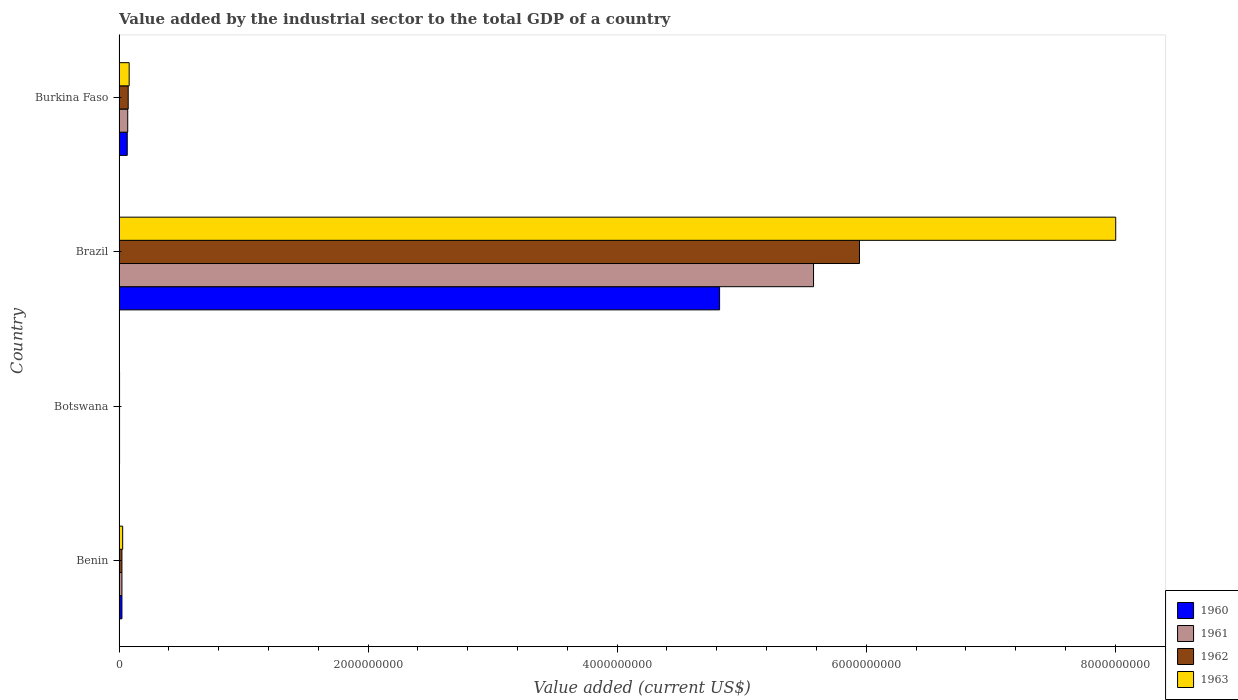How many different coloured bars are there?
Ensure brevity in your answer.  4. How many groups of bars are there?
Your answer should be very brief. 4. Are the number of bars on each tick of the Y-axis equal?
Offer a terse response. Yes. What is the label of the 4th group of bars from the top?
Your answer should be very brief. Benin. What is the value added by the industrial sector to the total GDP in 1962 in Brazil?
Ensure brevity in your answer.  5.95e+09. Across all countries, what is the maximum value added by the industrial sector to the total GDP in 1960?
Offer a terse response. 4.82e+09. Across all countries, what is the minimum value added by the industrial sector to the total GDP in 1961?
Provide a short and direct response. 4.05e+06. In which country was the value added by the industrial sector to the total GDP in 1963 minimum?
Ensure brevity in your answer.  Botswana. What is the total value added by the industrial sector to the total GDP in 1963 in the graph?
Your answer should be compact. 8.12e+09. What is the difference between the value added by the industrial sector to the total GDP in 1963 in Benin and that in Brazil?
Keep it short and to the point. -7.97e+09. What is the difference between the value added by the industrial sector to the total GDP in 1963 in Brazil and the value added by the industrial sector to the total GDP in 1962 in Burkina Faso?
Your answer should be very brief. 7.93e+09. What is the average value added by the industrial sector to the total GDP in 1960 per country?
Offer a very short reply. 1.23e+09. What is the difference between the value added by the industrial sector to the total GDP in 1963 and value added by the industrial sector to the total GDP in 1962 in Burkina Faso?
Your answer should be very brief. 7.75e+06. What is the ratio of the value added by the industrial sector to the total GDP in 1960 in Brazil to that in Burkina Faso?
Offer a terse response. 73.29. Is the value added by the industrial sector to the total GDP in 1961 in Brazil less than that in Burkina Faso?
Keep it short and to the point. No. Is the difference between the value added by the industrial sector to the total GDP in 1963 in Benin and Burkina Faso greater than the difference between the value added by the industrial sector to the total GDP in 1962 in Benin and Burkina Faso?
Keep it short and to the point. No. What is the difference between the highest and the second highest value added by the industrial sector to the total GDP in 1963?
Provide a short and direct response. 7.92e+09. What is the difference between the highest and the lowest value added by the industrial sector to the total GDP in 1963?
Offer a very short reply. 8.00e+09. In how many countries, is the value added by the industrial sector to the total GDP in 1961 greater than the average value added by the industrial sector to the total GDP in 1961 taken over all countries?
Provide a short and direct response. 1. Is it the case that in every country, the sum of the value added by the industrial sector to the total GDP in 1961 and value added by the industrial sector to the total GDP in 1960 is greater than the sum of value added by the industrial sector to the total GDP in 1962 and value added by the industrial sector to the total GDP in 1963?
Your answer should be very brief. No. What does the 2nd bar from the bottom in Burkina Faso represents?
Make the answer very short. 1961. Is it the case that in every country, the sum of the value added by the industrial sector to the total GDP in 1963 and value added by the industrial sector to the total GDP in 1962 is greater than the value added by the industrial sector to the total GDP in 1961?
Your answer should be very brief. Yes. How many bars are there?
Provide a short and direct response. 16. Are all the bars in the graph horizontal?
Provide a succinct answer. Yes. What is the difference between two consecutive major ticks on the X-axis?
Make the answer very short. 2.00e+09. Does the graph contain grids?
Offer a terse response. No. How many legend labels are there?
Your answer should be very brief. 4. How are the legend labels stacked?
Your response must be concise. Vertical. What is the title of the graph?
Your answer should be compact. Value added by the industrial sector to the total GDP of a country. Does "2007" appear as one of the legend labels in the graph?
Provide a short and direct response. No. What is the label or title of the X-axis?
Make the answer very short. Value added (current US$). What is the Value added (current US$) in 1960 in Benin?
Offer a very short reply. 2.31e+07. What is the Value added (current US$) of 1961 in Benin?
Offer a terse response. 2.31e+07. What is the Value added (current US$) in 1962 in Benin?
Offer a terse response. 2.32e+07. What is the Value added (current US$) in 1963 in Benin?
Ensure brevity in your answer.  2.91e+07. What is the Value added (current US$) in 1960 in Botswana?
Ensure brevity in your answer.  4.05e+06. What is the Value added (current US$) of 1961 in Botswana?
Ensure brevity in your answer.  4.05e+06. What is the Value added (current US$) in 1962 in Botswana?
Make the answer very short. 4.05e+06. What is the Value added (current US$) of 1963 in Botswana?
Your response must be concise. 4.04e+06. What is the Value added (current US$) of 1960 in Brazil?
Make the answer very short. 4.82e+09. What is the Value added (current US$) of 1961 in Brazil?
Offer a very short reply. 5.58e+09. What is the Value added (current US$) of 1962 in Brazil?
Provide a succinct answer. 5.95e+09. What is the Value added (current US$) in 1963 in Brazil?
Offer a very short reply. 8.00e+09. What is the Value added (current US$) of 1960 in Burkina Faso?
Your answer should be compact. 6.58e+07. What is the Value added (current US$) of 1961 in Burkina Faso?
Your response must be concise. 6.97e+07. What is the Value added (current US$) in 1962 in Burkina Faso?
Provide a succinct answer. 7.35e+07. What is the Value added (current US$) of 1963 in Burkina Faso?
Your answer should be very brief. 8.13e+07. Across all countries, what is the maximum Value added (current US$) in 1960?
Make the answer very short. 4.82e+09. Across all countries, what is the maximum Value added (current US$) in 1961?
Offer a very short reply. 5.58e+09. Across all countries, what is the maximum Value added (current US$) in 1962?
Provide a succinct answer. 5.95e+09. Across all countries, what is the maximum Value added (current US$) in 1963?
Ensure brevity in your answer.  8.00e+09. Across all countries, what is the minimum Value added (current US$) of 1960?
Offer a very short reply. 4.05e+06. Across all countries, what is the minimum Value added (current US$) of 1961?
Make the answer very short. 4.05e+06. Across all countries, what is the minimum Value added (current US$) of 1962?
Give a very brief answer. 4.05e+06. Across all countries, what is the minimum Value added (current US$) of 1963?
Give a very brief answer. 4.04e+06. What is the total Value added (current US$) in 1960 in the graph?
Your response must be concise. 4.92e+09. What is the total Value added (current US$) in 1961 in the graph?
Provide a short and direct response. 5.67e+09. What is the total Value added (current US$) in 1962 in the graph?
Your response must be concise. 6.05e+09. What is the total Value added (current US$) of 1963 in the graph?
Ensure brevity in your answer.  8.12e+09. What is the difference between the Value added (current US$) in 1960 in Benin and that in Botswana?
Your answer should be compact. 1.91e+07. What is the difference between the Value added (current US$) in 1961 in Benin and that in Botswana?
Your answer should be very brief. 1.91e+07. What is the difference between the Value added (current US$) in 1962 in Benin and that in Botswana?
Keep it short and to the point. 1.91e+07. What is the difference between the Value added (current US$) in 1963 in Benin and that in Botswana?
Your answer should be very brief. 2.51e+07. What is the difference between the Value added (current US$) in 1960 in Benin and that in Brazil?
Ensure brevity in your answer.  -4.80e+09. What is the difference between the Value added (current US$) of 1961 in Benin and that in Brazil?
Ensure brevity in your answer.  -5.55e+09. What is the difference between the Value added (current US$) of 1962 in Benin and that in Brazil?
Your answer should be compact. -5.92e+09. What is the difference between the Value added (current US$) of 1963 in Benin and that in Brazil?
Give a very brief answer. -7.97e+09. What is the difference between the Value added (current US$) of 1960 in Benin and that in Burkina Faso?
Provide a short and direct response. -4.27e+07. What is the difference between the Value added (current US$) of 1961 in Benin and that in Burkina Faso?
Keep it short and to the point. -4.66e+07. What is the difference between the Value added (current US$) in 1962 in Benin and that in Burkina Faso?
Offer a very short reply. -5.04e+07. What is the difference between the Value added (current US$) in 1963 in Benin and that in Burkina Faso?
Ensure brevity in your answer.  -5.21e+07. What is the difference between the Value added (current US$) of 1960 in Botswana and that in Brazil?
Provide a short and direct response. -4.82e+09. What is the difference between the Value added (current US$) of 1961 in Botswana and that in Brazil?
Your response must be concise. -5.57e+09. What is the difference between the Value added (current US$) of 1962 in Botswana and that in Brazil?
Your response must be concise. -5.94e+09. What is the difference between the Value added (current US$) of 1963 in Botswana and that in Brazil?
Provide a short and direct response. -8.00e+09. What is the difference between the Value added (current US$) in 1960 in Botswana and that in Burkina Faso?
Provide a short and direct response. -6.17e+07. What is the difference between the Value added (current US$) of 1961 in Botswana and that in Burkina Faso?
Ensure brevity in your answer.  -6.56e+07. What is the difference between the Value added (current US$) in 1962 in Botswana and that in Burkina Faso?
Your answer should be very brief. -6.95e+07. What is the difference between the Value added (current US$) in 1963 in Botswana and that in Burkina Faso?
Give a very brief answer. -7.72e+07. What is the difference between the Value added (current US$) in 1960 in Brazil and that in Burkina Faso?
Your response must be concise. 4.76e+09. What is the difference between the Value added (current US$) in 1961 in Brazil and that in Burkina Faso?
Your answer should be very brief. 5.51e+09. What is the difference between the Value added (current US$) of 1962 in Brazil and that in Burkina Faso?
Your answer should be very brief. 5.87e+09. What is the difference between the Value added (current US$) of 1963 in Brazil and that in Burkina Faso?
Your response must be concise. 7.92e+09. What is the difference between the Value added (current US$) of 1960 in Benin and the Value added (current US$) of 1961 in Botswana?
Your answer should be very brief. 1.91e+07. What is the difference between the Value added (current US$) of 1960 in Benin and the Value added (current US$) of 1962 in Botswana?
Your answer should be compact. 1.91e+07. What is the difference between the Value added (current US$) in 1960 in Benin and the Value added (current US$) in 1963 in Botswana?
Ensure brevity in your answer.  1.91e+07. What is the difference between the Value added (current US$) in 1961 in Benin and the Value added (current US$) in 1962 in Botswana?
Offer a terse response. 1.91e+07. What is the difference between the Value added (current US$) in 1961 in Benin and the Value added (current US$) in 1963 in Botswana?
Give a very brief answer. 1.91e+07. What is the difference between the Value added (current US$) in 1962 in Benin and the Value added (current US$) in 1963 in Botswana?
Offer a very short reply. 1.91e+07. What is the difference between the Value added (current US$) of 1960 in Benin and the Value added (current US$) of 1961 in Brazil?
Your answer should be compact. -5.55e+09. What is the difference between the Value added (current US$) in 1960 in Benin and the Value added (current US$) in 1962 in Brazil?
Keep it short and to the point. -5.92e+09. What is the difference between the Value added (current US$) in 1960 in Benin and the Value added (current US$) in 1963 in Brazil?
Your response must be concise. -7.98e+09. What is the difference between the Value added (current US$) in 1961 in Benin and the Value added (current US$) in 1962 in Brazil?
Ensure brevity in your answer.  -5.92e+09. What is the difference between the Value added (current US$) of 1961 in Benin and the Value added (current US$) of 1963 in Brazil?
Your response must be concise. -7.98e+09. What is the difference between the Value added (current US$) of 1962 in Benin and the Value added (current US$) of 1963 in Brazil?
Offer a very short reply. -7.98e+09. What is the difference between the Value added (current US$) in 1960 in Benin and the Value added (current US$) in 1961 in Burkina Faso?
Keep it short and to the point. -4.65e+07. What is the difference between the Value added (current US$) of 1960 in Benin and the Value added (current US$) of 1962 in Burkina Faso?
Ensure brevity in your answer.  -5.04e+07. What is the difference between the Value added (current US$) of 1960 in Benin and the Value added (current US$) of 1963 in Burkina Faso?
Provide a short and direct response. -5.81e+07. What is the difference between the Value added (current US$) in 1961 in Benin and the Value added (current US$) in 1962 in Burkina Faso?
Provide a succinct answer. -5.04e+07. What is the difference between the Value added (current US$) in 1961 in Benin and the Value added (current US$) in 1963 in Burkina Faso?
Your response must be concise. -5.81e+07. What is the difference between the Value added (current US$) of 1962 in Benin and the Value added (current US$) of 1963 in Burkina Faso?
Provide a succinct answer. -5.81e+07. What is the difference between the Value added (current US$) in 1960 in Botswana and the Value added (current US$) in 1961 in Brazil?
Your answer should be very brief. -5.57e+09. What is the difference between the Value added (current US$) of 1960 in Botswana and the Value added (current US$) of 1962 in Brazil?
Ensure brevity in your answer.  -5.94e+09. What is the difference between the Value added (current US$) in 1960 in Botswana and the Value added (current US$) in 1963 in Brazil?
Give a very brief answer. -8.00e+09. What is the difference between the Value added (current US$) in 1961 in Botswana and the Value added (current US$) in 1962 in Brazil?
Keep it short and to the point. -5.94e+09. What is the difference between the Value added (current US$) of 1961 in Botswana and the Value added (current US$) of 1963 in Brazil?
Give a very brief answer. -8.00e+09. What is the difference between the Value added (current US$) in 1962 in Botswana and the Value added (current US$) in 1963 in Brazil?
Make the answer very short. -8.00e+09. What is the difference between the Value added (current US$) in 1960 in Botswana and the Value added (current US$) in 1961 in Burkina Faso?
Ensure brevity in your answer.  -6.56e+07. What is the difference between the Value added (current US$) in 1960 in Botswana and the Value added (current US$) in 1962 in Burkina Faso?
Offer a terse response. -6.95e+07. What is the difference between the Value added (current US$) in 1960 in Botswana and the Value added (current US$) in 1963 in Burkina Faso?
Provide a succinct answer. -7.72e+07. What is the difference between the Value added (current US$) of 1961 in Botswana and the Value added (current US$) of 1962 in Burkina Faso?
Your answer should be very brief. -6.95e+07. What is the difference between the Value added (current US$) in 1961 in Botswana and the Value added (current US$) in 1963 in Burkina Faso?
Make the answer very short. -7.72e+07. What is the difference between the Value added (current US$) in 1962 in Botswana and the Value added (current US$) in 1963 in Burkina Faso?
Your response must be concise. -7.72e+07. What is the difference between the Value added (current US$) in 1960 in Brazil and the Value added (current US$) in 1961 in Burkina Faso?
Keep it short and to the point. 4.75e+09. What is the difference between the Value added (current US$) in 1960 in Brazil and the Value added (current US$) in 1962 in Burkina Faso?
Your answer should be very brief. 4.75e+09. What is the difference between the Value added (current US$) in 1960 in Brazil and the Value added (current US$) in 1963 in Burkina Faso?
Your answer should be very brief. 4.74e+09. What is the difference between the Value added (current US$) in 1961 in Brazil and the Value added (current US$) in 1962 in Burkina Faso?
Give a very brief answer. 5.50e+09. What is the difference between the Value added (current US$) of 1961 in Brazil and the Value added (current US$) of 1963 in Burkina Faso?
Provide a short and direct response. 5.50e+09. What is the difference between the Value added (current US$) of 1962 in Brazil and the Value added (current US$) of 1963 in Burkina Faso?
Provide a short and direct response. 5.86e+09. What is the average Value added (current US$) in 1960 per country?
Your answer should be compact. 1.23e+09. What is the average Value added (current US$) of 1961 per country?
Keep it short and to the point. 1.42e+09. What is the average Value added (current US$) in 1962 per country?
Offer a very short reply. 1.51e+09. What is the average Value added (current US$) in 1963 per country?
Your response must be concise. 2.03e+09. What is the difference between the Value added (current US$) in 1960 and Value added (current US$) in 1961 in Benin?
Ensure brevity in your answer.  6130.83. What is the difference between the Value added (current US$) of 1960 and Value added (current US$) of 1962 in Benin?
Ensure brevity in your answer.  -1.71e+04. What is the difference between the Value added (current US$) in 1960 and Value added (current US$) in 1963 in Benin?
Make the answer very short. -5.99e+06. What is the difference between the Value added (current US$) of 1961 and Value added (current US$) of 1962 in Benin?
Ensure brevity in your answer.  -2.32e+04. What is the difference between the Value added (current US$) in 1961 and Value added (current US$) in 1963 in Benin?
Ensure brevity in your answer.  -6.00e+06. What is the difference between the Value added (current US$) in 1962 and Value added (current US$) in 1963 in Benin?
Make the answer very short. -5.97e+06. What is the difference between the Value added (current US$) in 1960 and Value added (current US$) in 1961 in Botswana?
Give a very brief answer. 7791.27. What is the difference between the Value added (current US$) of 1960 and Value added (current US$) of 1962 in Botswana?
Offer a very short reply. -314.81. What is the difference between the Value added (current US$) in 1960 and Value added (current US$) in 1963 in Botswana?
Your response must be concise. 1.11e+04. What is the difference between the Value added (current US$) in 1961 and Value added (current US$) in 1962 in Botswana?
Your response must be concise. -8106.08. What is the difference between the Value added (current US$) in 1961 and Value added (current US$) in 1963 in Botswana?
Your answer should be very brief. 3353.04. What is the difference between the Value added (current US$) in 1962 and Value added (current US$) in 1963 in Botswana?
Offer a very short reply. 1.15e+04. What is the difference between the Value added (current US$) in 1960 and Value added (current US$) in 1961 in Brazil?
Provide a succinct answer. -7.55e+08. What is the difference between the Value added (current US$) of 1960 and Value added (current US$) of 1962 in Brazil?
Your answer should be compact. -1.12e+09. What is the difference between the Value added (current US$) of 1960 and Value added (current US$) of 1963 in Brazil?
Give a very brief answer. -3.18e+09. What is the difference between the Value added (current US$) in 1961 and Value added (current US$) in 1962 in Brazil?
Give a very brief answer. -3.69e+08. What is the difference between the Value added (current US$) of 1961 and Value added (current US$) of 1963 in Brazil?
Provide a succinct answer. -2.43e+09. What is the difference between the Value added (current US$) in 1962 and Value added (current US$) in 1963 in Brazil?
Offer a very short reply. -2.06e+09. What is the difference between the Value added (current US$) of 1960 and Value added (current US$) of 1961 in Burkina Faso?
Your answer should be compact. -3.88e+06. What is the difference between the Value added (current US$) of 1960 and Value added (current US$) of 1962 in Burkina Faso?
Your answer should be compact. -7.71e+06. What is the difference between the Value added (current US$) of 1960 and Value added (current US$) of 1963 in Burkina Faso?
Keep it short and to the point. -1.55e+07. What is the difference between the Value added (current US$) of 1961 and Value added (current US$) of 1962 in Burkina Faso?
Your answer should be very brief. -3.83e+06. What is the difference between the Value added (current US$) in 1961 and Value added (current US$) in 1963 in Burkina Faso?
Offer a very short reply. -1.16e+07. What is the difference between the Value added (current US$) of 1962 and Value added (current US$) of 1963 in Burkina Faso?
Offer a very short reply. -7.75e+06. What is the ratio of the Value added (current US$) in 1960 in Benin to that in Botswana?
Give a very brief answer. 5.71. What is the ratio of the Value added (current US$) of 1961 in Benin to that in Botswana?
Ensure brevity in your answer.  5.72. What is the ratio of the Value added (current US$) of 1962 in Benin to that in Botswana?
Give a very brief answer. 5.71. What is the ratio of the Value added (current US$) of 1963 in Benin to that in Botswana?
Ensure brevity in your answer.  7.2. What is the ratio of the Value added (current US$) of 1960 in Benin to that in Brazil?
Keep it short and to the point. 0. What is the ratio of the Value added (current US$) of 1961 in Benin to that in Brazil?
Your answer should be very brief. 0. What is the ratio of the Value added (current US$) in 1962 in Benin to that in Brazil?
Provide a succinct answer. 0. What is the ratio of the Value added (current US$) in 1963 in Benin to that in Brazil?
Provide a short and direct response. 0. What is the ratio of the Value added (current US$) of 1960 in Benin to that in Burkina Faso?
Your answer should be compact. 0.35. What is the ratio of the Value added (current US$) in 1961 in Benin to that in Burkina Faso?
Your response must be concise. 0.33. What is the ratio of the Value added (current US$) in 1962 in Benin to that in Burkina Faso?
Keep it short and to the point. 0.31. What is the ratio of the Value added (current US$) of 1963 in Benin to that in Burkina Faso?
Offer a terse response. 0.36. What is the ratio of the Value added (current US$) of 1960 in Botswana to that in Brazil?
Your answer should be compact. 0. What is the ratio of the Value added (current US$) of 1961 in Botswana to that in Brazil?
Your answer should be very brief. 0. What is the ratio of the Value added (current US$) in 1962 in Botswana to that in Brazil?
Your response must be concise. 0. What is the ratio of the Value added (current US$) of 1963 in Botswana to that in Brazil?
Ensure brevity in your answer.  0. What is the ratio of the Value added (current US$) in 1960 in Botswana to that in Burkina Faso?
Offer a terse response. 0.06. What is the ratio of the Value added (current US$) in 1961 in Botswana to that in Burkina Faso?
Your answer should be compact. 0.06. What is the ratio of the Value added (current US$) in 1962 in Botswana to that in Burkina Faso?
Keep it short and to the point. 0.06. What is the ratio of the Value added (current US$) in 1963 in Botswana to that in Burkina Faso?
Provide a short and direct response. 0.05. What is the ratio of the Value added (current US$) of 1960 in Brazil to that in Burkina Faso?
Your answer should be compact. 73.29. What is the ratio of the Value added (current US$) of 1961 in Brazil to that in Burkina Faso?
Your answer should be very brief. 80.04. What is the ratio of the Value added (current US$) of 1962 in Brazil to that in Burkina Faso?
Your answer should be compact. 80.89. What is the ratio of the Value added (current US$) of 1963 in Brazil to that in Burkina Faso?
Offer a very short reply. 98.49. What is the difference between the highest and the second highest Value added (current US$) of 1960?
Provide a succinct answer. 4.76e+09. What is the difference between the highest and the second highest Value added (current US$) in 1961?
Provide a succinct answer. 5.51e+09. What is the difference between the highest and the second highest Value added (current US$) in 1962?
Provide a short and direct response. 5.87e+09. What is the difference between the highest and the second highest Value added (current US$) in 1963?
Your answer should be very brief. 7.92e+09. What is the difference between the highest and the lowest Value added (current US$) of 1960?
Keep it short and to the point. 4.82e+09. What is the difference between the highest and the lowest Value added (current US$) in 1961?
Keep it short and to the point. 5.57e+09. What is the difference between the highest and the lowest Value added (current US$) in 1962?
Ensure brevity in your answer.  5.94e+09. What is the difference between the highest and the lowest Value added (current US$) of 1963?
Give a very brief answer. 8.00e+09. 